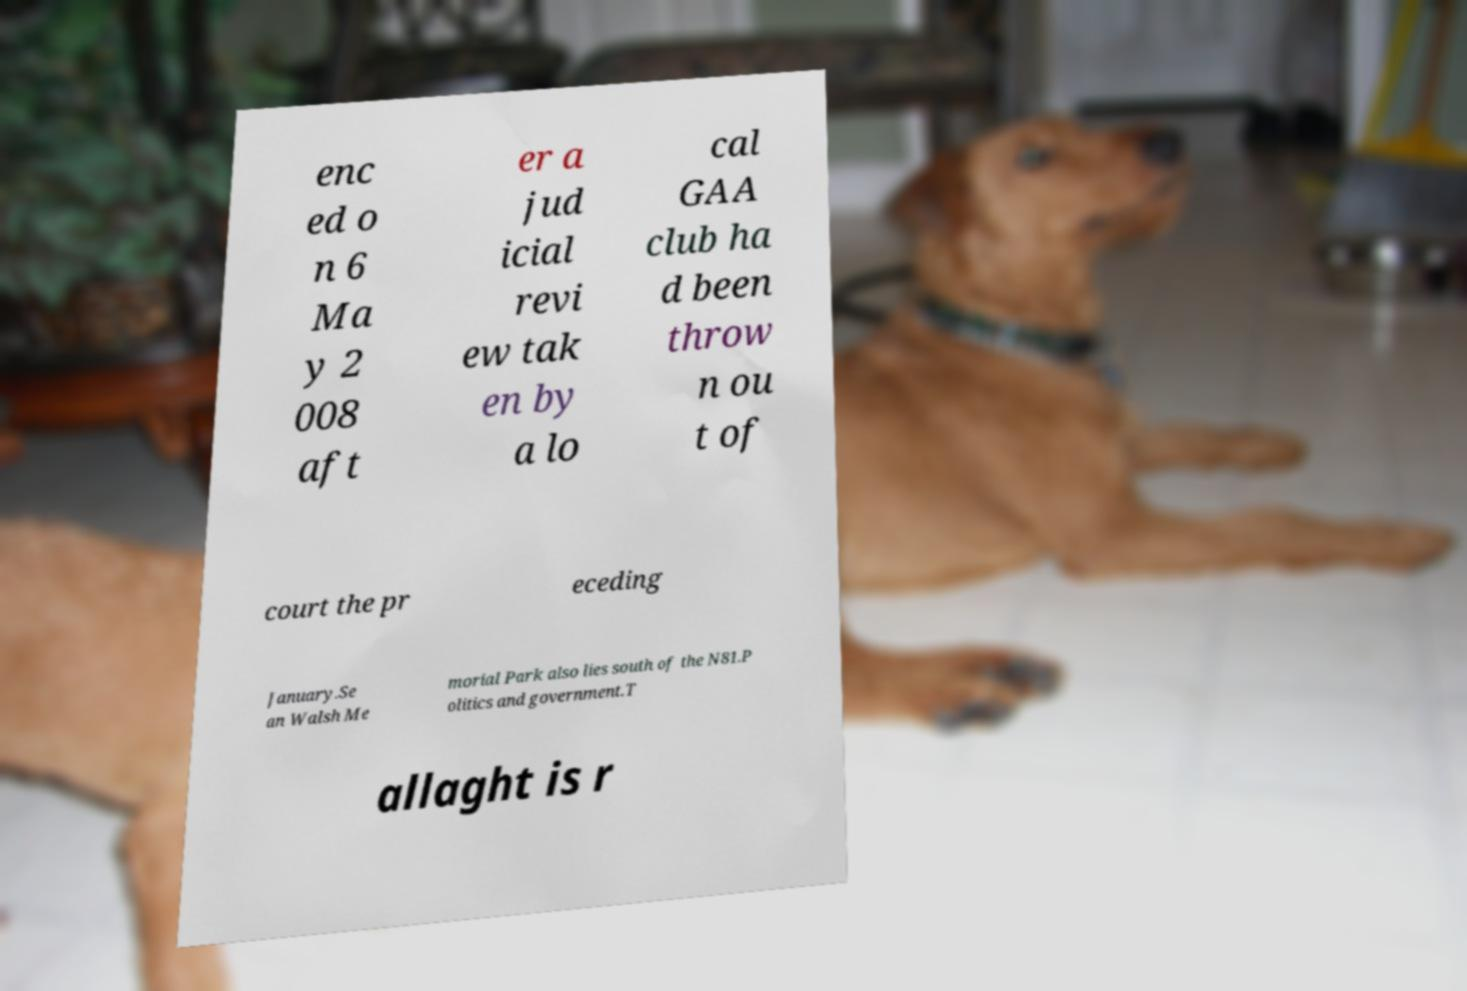There's text embedded in this image that I need extracted. Can you transcribe it verbatim? enc ed o n 6 Ma y 2 008 aft er a jud icial revi ew tak en by a lo cal GAA club ha d been throw n ou t of court the pr eceding January.Se an Walsh Me morial Park also lies south of the N81.P olitics and government.T allaght is r 